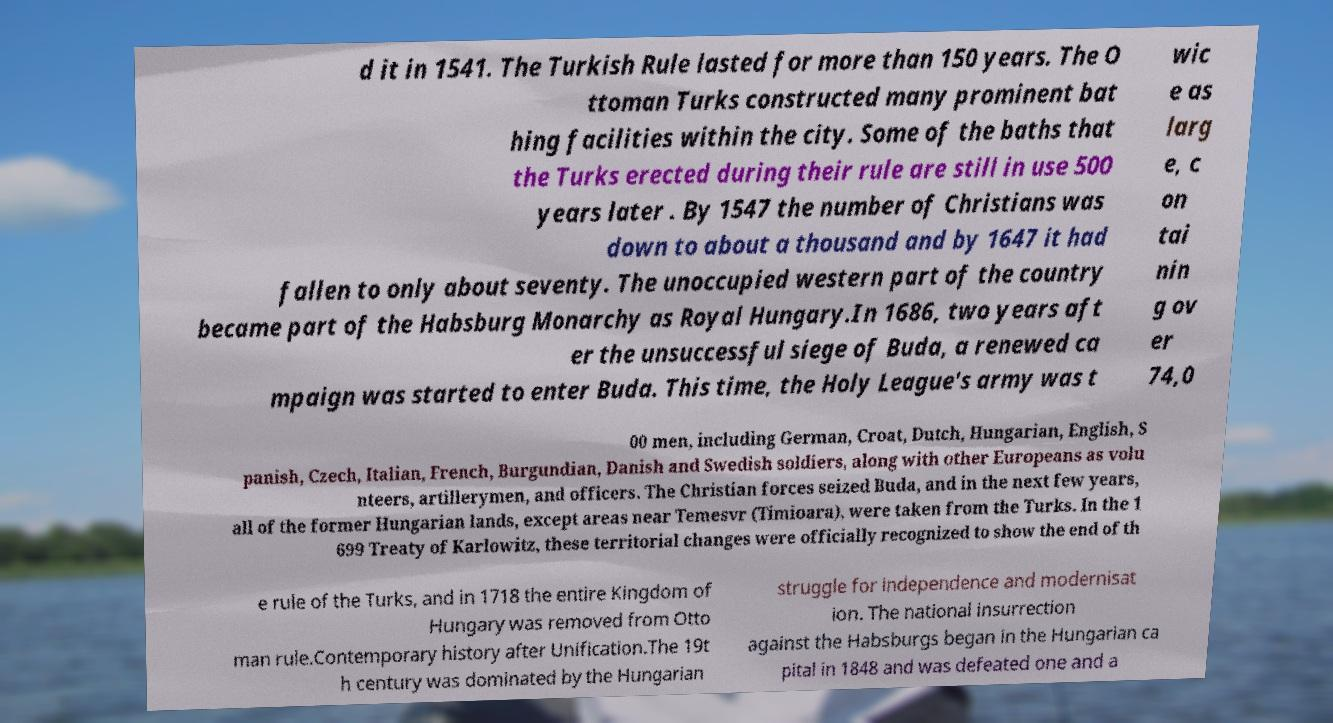Can you read and provide the text displayed in the image?This photo seems to have some interesting text. Can you extract and type it out for me? d it in 1541. The Turkish Rule lasted for more than 150 years. The O ttoman Turks constructed many prominent bat hing facilities within the city. Some of the baths that the Turks erected during their rule are still in use 500 years later . By 1547 the number of Christians was down to about a thousand and by 1647 it had fallen to only about seventy. The unoccupied western part of the country became part of the Habsburg Monarchy as Royal Hungary.In 1686, two years aft er the unsuccessful siege of Buda, a renewed ca mpaign was started to enter Buda. This time, the Holy League's army was t wic e as larg e, c on tai nin g ov er 74,0 00 men, including German, Croat, Dutch, Hungarian, English, S panish, Czech, Italian, French, Burgundian, Danish and Swedish soldiers, along with other Europeans as volu nteers, artillerymen, and officers. The Christian forces seized Buda, and in the next few years, all of the former Hungarian lands, except areas near Temesvr (Timioara), were taken from the Turks. In the 1 699 Treaty of Karlowitz, these territorial changes were officially recognized to show the end of th e rule of the Turks, and in 1718 the entire Kingdom of Hungary was removed from Otto man rule.Contemporary history after Unification.The 19t h century was dominated by the Hungarian struggle for independence and modernisat ion. The national insurrection against the Habsburgs began in the Hungarian ca pital in 1848 and was defeated one and a 